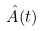Convert formula to latex. <formula><loc_0><loc_0><loc_500><loc_500>\hat { A } ( t )</formula> 